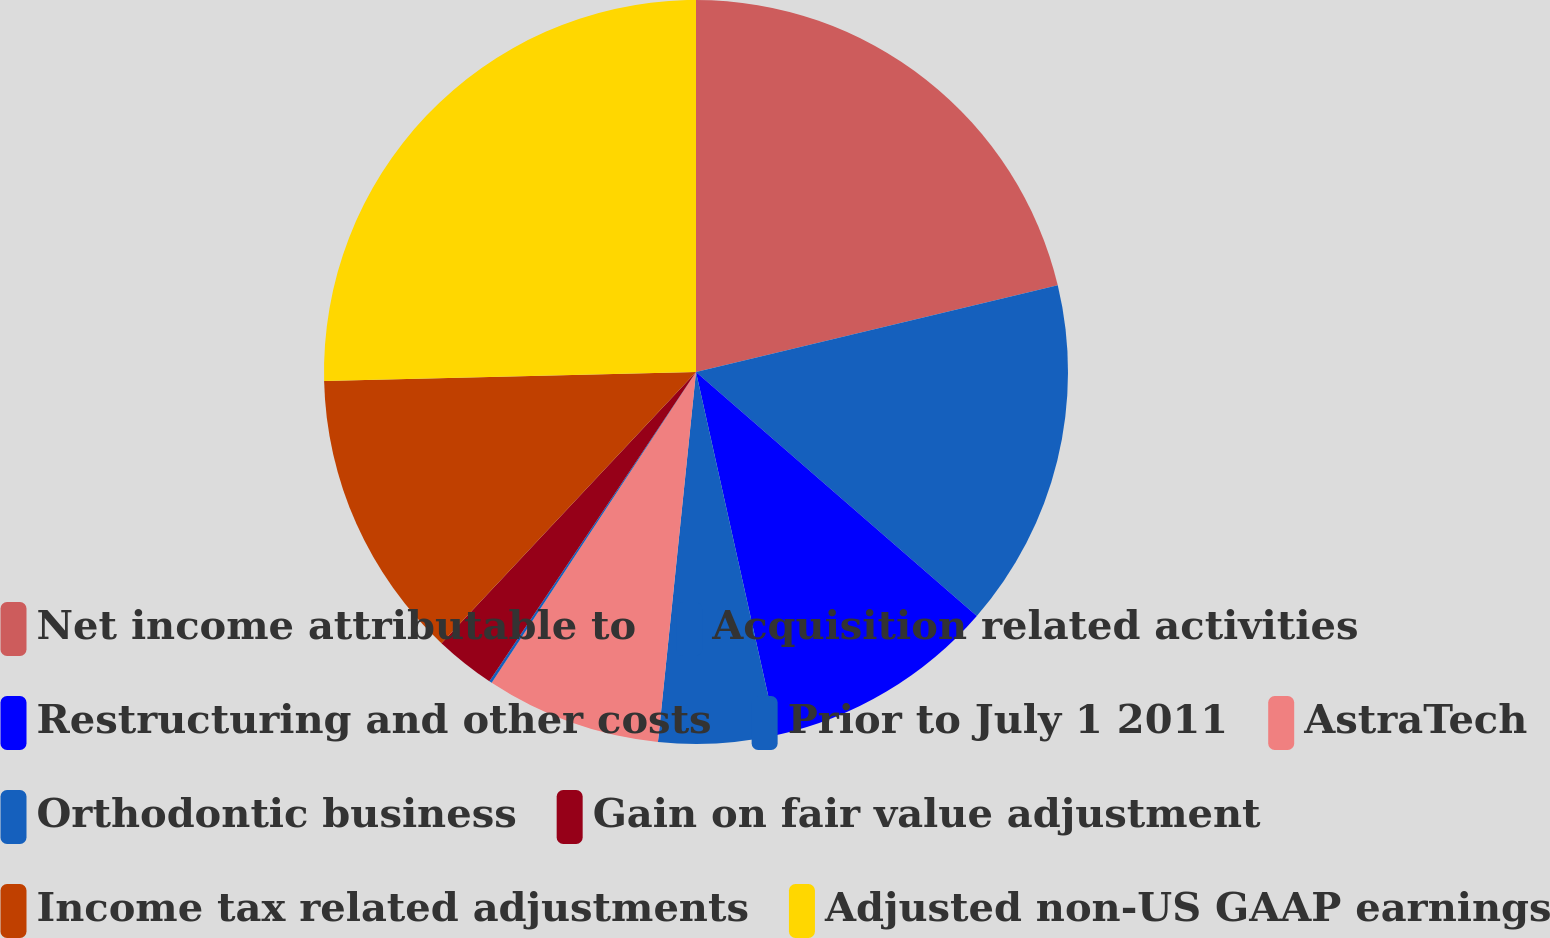<chart> <loc_0><loc_0><loc_500><loc_500><pie_chart><fcel>Net income attributable to<fcel>Acquisition related activities<fcel>Restructuring and other costs<fcel>Prior to July 1 2011<fcel>AstraTech<fcel>Orthodontic business<fcel>Gain on fair value adjustment<fcel>Income tax related adjustments<fcel>Adjusted non-US GAAP earnings<nl><fcel>21.25%<fcel>15.12%<fcel>10.12%<fcel>5.12%<fcel>7.62%<fcel>0.12%<fcel>2.62%<fcel>12.62%<fcel>25.37%<nl></chart> 